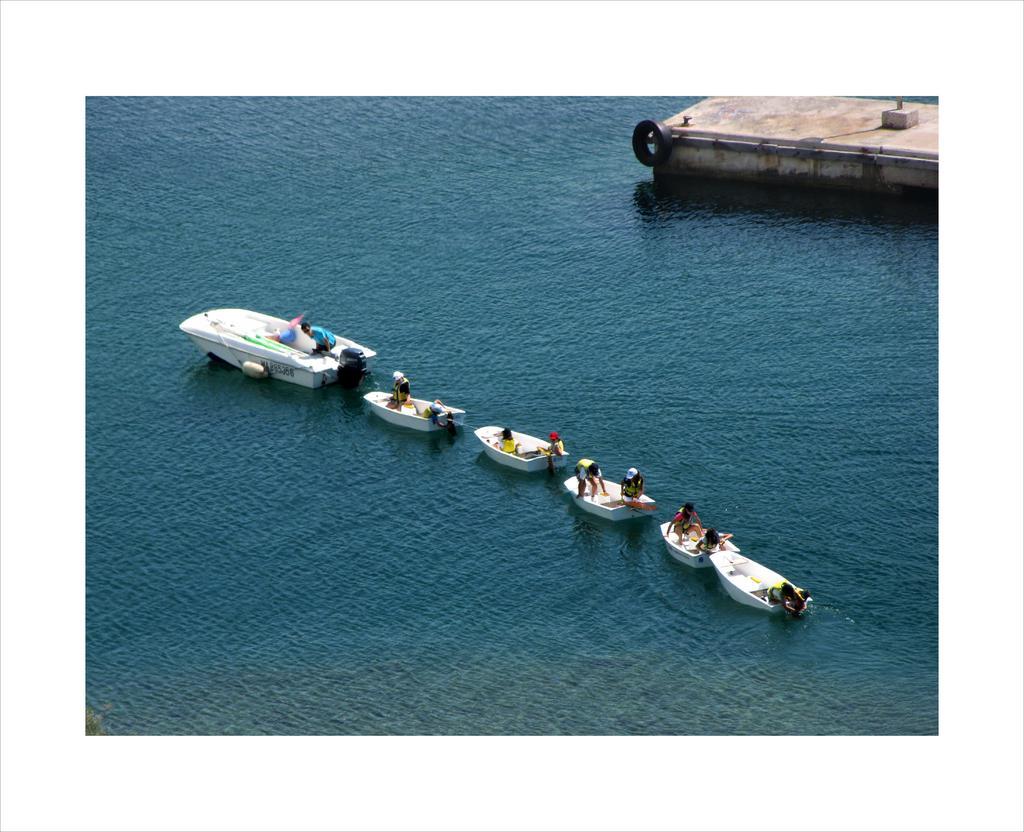Describe this image in one or two sentences. In this image we can see boats. There are people in boats. At the bottom of the image there is water. To the top right corner of the image there is a concrete surface. There is a Tyre and pipes. 